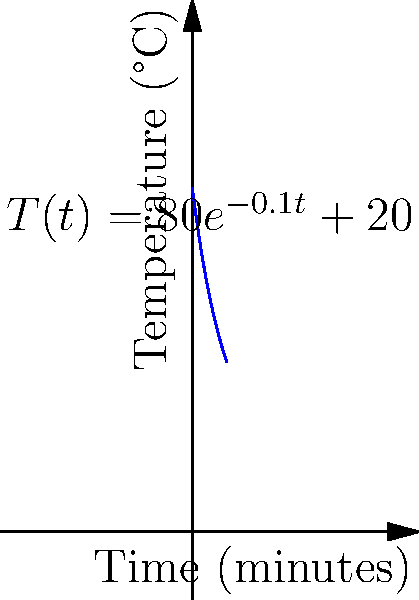As a chef, you're cooling a hot dish and monitoring its temperature over time. The temperature $T$ (in °C) of the dish $t$ minutes after removing it from the oven is given by the function $T(t) = 80e^{-0.1t} + 20$. At what rate is the temperature changing after 5 minutes? Your teacher always emphasizes the importance of precise calculations in the kitchen. Let's approach this step-by-step, as your culinary teacher would appreciate:

1) The rate of temperature change is given by the derivative of the temperature function with respect to time.

2) We need to find $\frac{dT}{dt}$ and then evaluate it at $t=5$.

3) To find $\frac{dT}{dt}$, we use the chain rule:

   $\frac{dT}{dt} = 80 \cdot \frac{d}{dt}(e^{-0.1t}) + \frac{d}{dt}(20)$

4) We know that $\frac{d}{dt}(e^{ax}) = ae^{ax}$, so:

   $\frac{dT}{dt} = 80 \cdot (-0.1)e^{-0.1t} + 0 = -8e^{-0.1t}$

5) Now, we evaluate this at $t=5$:

   $\frac{dT}{dt}|_{t=5} = -8e^{-0.1(5)} = -8e^{-0.5}$

6) Using a calculator (as precise chefs often do):

   $-8e^{-0.5} \approx -4.87$ °C/min

7) The negative sign indicates that the temperature is decreasing.
Answer: $-4.87$ °C/min 